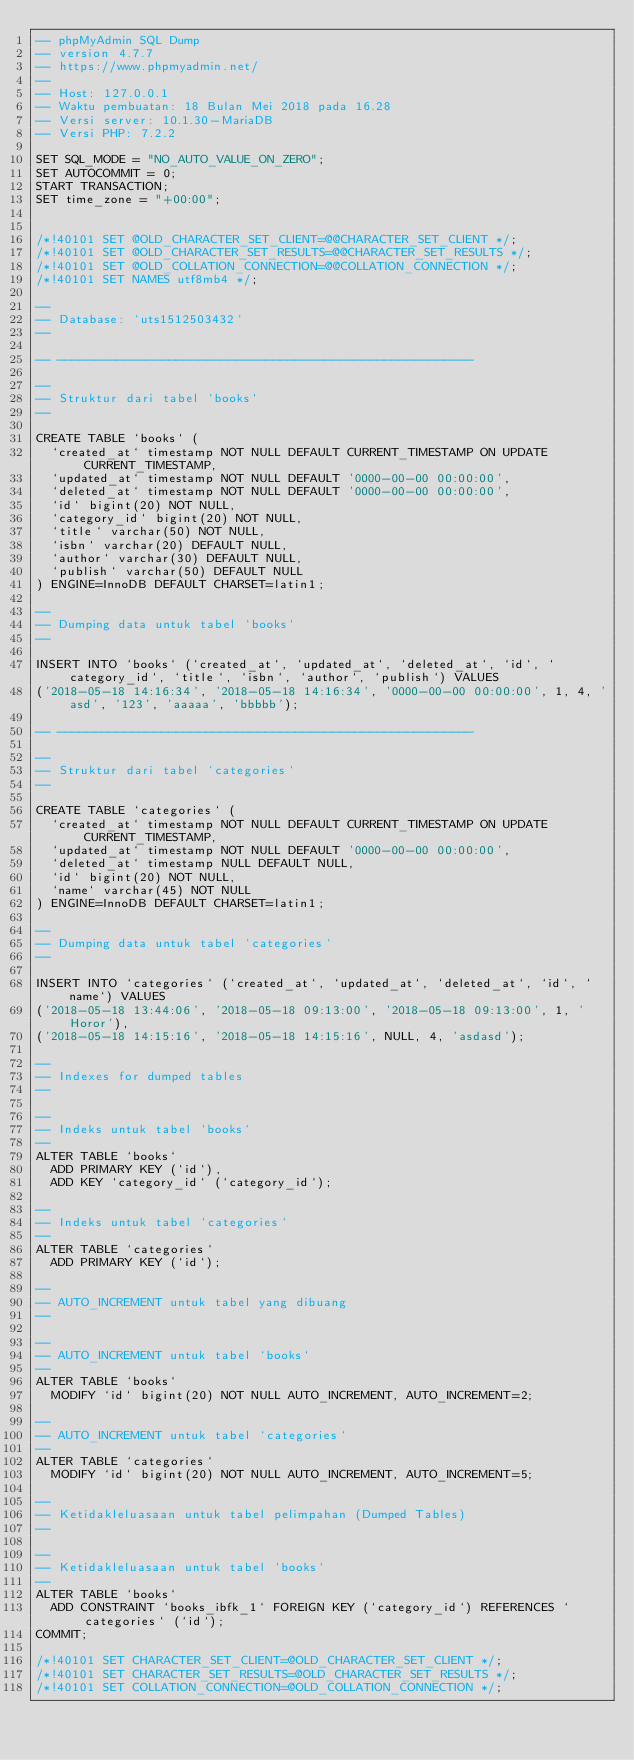Convert code to text. <code><loc_0><loc_0><loc_500><loc_500><_SQL_>-- phpMyAdmin SQL Dump
-- version 4.7.7
-- https://www.phpmyadmin.net/
--
-- Host: 127.0.0.1
-- Waktu pembuatan: 18 Bulan Mei 2018 pada 16.28
-- Versi server: 10.1.30-MariaDB
-- Versi PHP: 7.2.2

SET SQL_MODE = "NO_AUTO_VALUE_ON_ZERO";
SET AUTOCOMMIT = 0;
START TRANSACTION;
SET time_zone = "+00:00";


/*!40101 SET @OLD_CHARACTER_SET_CLIENT=@@CHARACTER_SET_CLIENT */;
/*!40101 SET @OLD_CHARACTER_SET_RESULTS=@@CHARACTER_SET_RESULTS */;
/*!40101 SET @OLD_COLLATION_CONNECTION=@@COLLATION_CONNECTION */;
/*!40101 SET NAMES utf8mb4 */;

--
-- Database: `uts1512503432`
--

-- --------------------------------------------------------

--
-- Struktur dari tabel `books`
--

CREATE TABLE `books` (
  `created_at` timestamp NOT NULL DEFAULT CURRENT_TIMESTAMP ON UPDATE CURRENT_TIMESTAMP,
  `updated_at` timestamp NOT NULL DEFAULT '0000-00-00 00:00:00',
  `deleted_at` timestamp NOT NULL DEFAULT '0000-00-00 00:00:00',
  `id` bigint(20) NOT NULL,
  `category_id` bigint(20) NOT NULL,
  `title` varchar(50) NOT NULL,
  `isbn` varchar(20) DEFAULT NULL,
  `author` varchar(30) DEFAULT NULL,
  `publish` varchar(50) DEFAULT NULL
) ENGINE=InnoDB DEFAULT CHARSET=latin1;

--
-- Dumping data untuk tabel `books`
--

INSERT INTO `books` (`created_at`, `updated_at`, `deleted_at`, `id`, `category_id`, `title`, `isbn`, `author`, `publish`) VALUES
('2018-05-18 14:16:34', '2018-05-18 14:16:34', '0000-00-00 00:00:00', 1, 4, 'asd', '123', 'aaaaa', 'bbbbb');

-- --------------------------------------------------------

--
-- Struktur dari tabel `categories`
--

CREATE TABLE `categories` (
  `created_at` timestamp NOT NULL DEFAULT CURRENT_TIMESTAMP ON UPDATE CURRENT_TIMESTAMP,
  `updated_at` timestamp NOT NULL DEFAULT '0000-00-00 00:00:00',
  `deleted_at` timestamp NULL DEFAULT NULL,
  `id` bigint(20) NOT NULL,
  `name` varchar(45) NOT NULL
) ENGINE=InnoDB DEFAULT CHARSET=latin1;

--
-- Dumping data untuk tabel `categories`
--

INSERT INTO `categories` (`created_at`, `updated_at`, `deleted_at`, `id`, `name`) VALUES
('2018-05-18 13:44:06', '2018-05-18 09:13:00', '2018-05-18 09:13:00', 1, 'Horor'),
('2018-05-18 14:15:16', '2018-05-18 14:15:16', NULL, 4, 'asdasd');

--
-- Indexes for dumped tables
--

--
-- Indeks untuk tabel `books`
--
ALTER TABLE `books`
  ADD PRIMARY KEY (`id`),
  ADD KEY `category_id` (`category_id`);

--
-- Indeks untuk tabel `categories`
--
ALTER TABLE `categories`
  ADD PRIMARY KEY (`id`);

--
-- AUTO_INCREMENT untuk tabel yang dibuang
--

--
-- AUTO_INCREMENT untuk tabel `books`
--
ALTER TABLE `books`
  MODIFY `id` bigint(20) NOT NULL AUTO_INCREMENT, AUTO_INCREMENT=2;

--
-- AUTO_INCREMENT untuk tabel `categories`
--
ALTER TABLE `categories`
  MODIFY `id` bigint(20) NOT NULL AUTO_INCREMENT, AUTO_INCREMENT=5;

--
-- Ketidakleluasaan untuk tabel pelimpahan (Dumped Tables)
--

--
-- Ketidakleluasaan untuk tabel `books`
--
ALTER TABLE `books`
  ADD CONSTRAINT `books_ibfk_1` FOREIGN KEY (`category_id`) REFERENCES `categories` (`id`);
COMMIT;

/*!40101 SET CHARACTER_SET_CLIENT=@OLD_CHARACTER_SET_CLIENT */;
/*!40101 SET CHARACTER_SET_RESULTS=@OLD_CHARACTER_SET_RESULTS */;
/*!40101 SET COLLATION_CONNECTION=@OLD_COLLATION_CONNECTION */;
</code> 